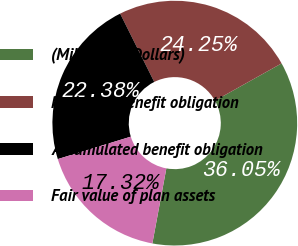Convert chart. <chart><loc_0><loc_0><loc_500><loc_500><pie_chart><fcel>(Millions of Dollars)<fcel>Projected benefit obligation<fcel>Accumulated benefit obligation<fcel>Fair value of plan assets<nl><fcel>36.05%<fcel>24.25%<fcel>22.38%<fcel>17.32%<nl></chart> 